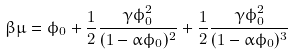Convert formula to latex. <formula><loc_0><loc_0><loc_500><loc_500>\beta \mu = \phi _ { 0 } + \frac { 1 } { 2 } \frac { \gamma \phi _ { 0 } ^ { 2 } } { ( 1 - \alpha \phi _ { 0 } ) ^ { 2 } } + \frac { 1 } { 2 } \frac { \gamma \phi _ { 0 } ^ { 2 } } { ( 1 - \alpha \phi _ { 0 } ) ^ { 3 } }</formula> 